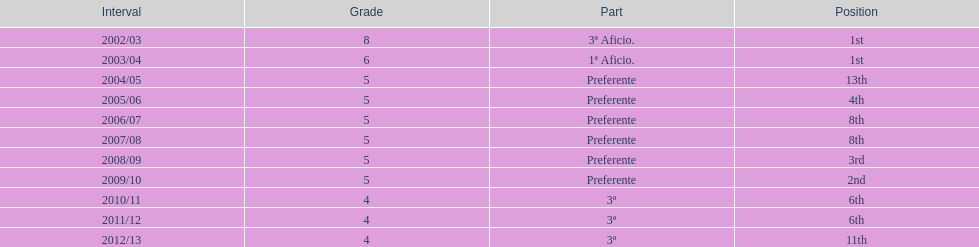Which division has the largest number of ranks? Preferente. 